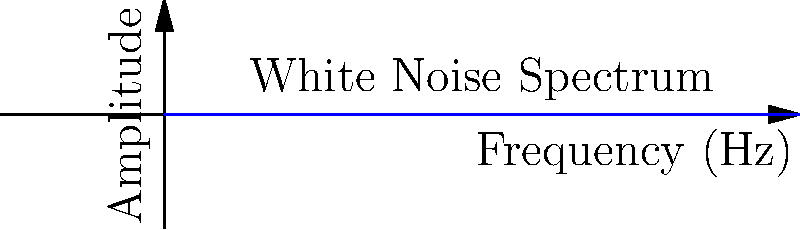A white noise generator is being designed for a sleep therapy device. Given that the human auditory range is typically 20 Hz to 20 kHz, and the generator should produce a constant power spectral density, what is the ratio of amplitudes for sound waves at 100 Hz compared to 10 kHz? To solve this problem, we need to understand the properties of white noise and apply the principles of sound wave physics:

1. White noise has a constant power spectral density, meaning equal power in all frequency bands of equal width.

2. The power of a sound wave is proportional to the square of its amplitude: $P \propto A^2$

3. For white noise, the power is constant across frequencies: $P_1 = P_2$

4. Therefore, $A_1^2 f_1 = A_2^2 f_2$, where $f$ is frequency and $A$ is amplitude.

5. We can express this as a ratio: $\frac{A_1}{A_2} = \sqrt{\frac{f_2}{f_1}}$

6. Given frequencies: $f_1 = 100$ Hz, $f_2 = 10,000$ Hz

7. Substituting into our ratio equation:

   $\frac{A_{100 \text{ Hz}}}{A_{10 \text{ kHz}}} = \sqrt{\frac{10,000 \text{ Hz}}{100 \text{ Hz}}} = \sqrt{100} = 10$

Therefore, the amplitude at 100 Hz is 10 times greater than the amplitude at 10 kHz.
Answer: 10:1 